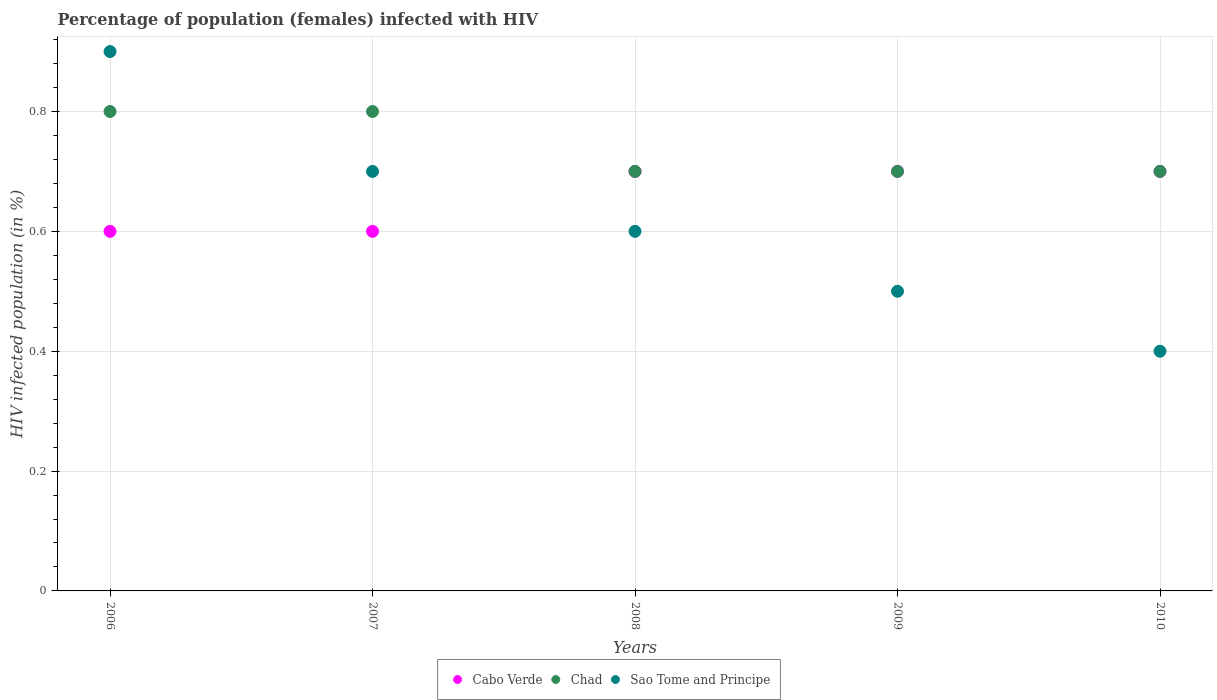Is the number of dotlines equal to the number of legend labels?
Your answer should be very brief. Yes. What is the percentage of HIV infected female population in Cabo Verde in 2008?
Your answer should be compact. 0.7. Across all years, what is the maximum percentage of HIV infected female population in Chad?
Offer a terse response. 0.8. Across all years, what is the minimum percentage of HIV infected female population in Chad?
Ensure brevity in your answer.  0.7. What is the total percentage of HIV infected female population in Cabo Verde in the graph?
Your answer should be very brief. 3.3. What is the difference between the percentage of HIV infected female population in Chad in 2007 and the percentage of HIV infected female population in Sao Tome and Principe in 2010?
Offer a terse response. 0.4. What is the average percentage of HIV infected female population in Cabo Verde per year?
Keep it short and to the point. 0.66. In the year 2007, what is the difference between the percentage of HIV infected female population in Sao Tome and Principe and percentage of HIV infected female population in Cabo Verde?
Offer a very short reply. 0.1. What is the ratio of the percentage of HIV infected female population in Sao Tome and Principe in 2006 to that in 2010?
Make the answer very short. 2.25. What is the difference between the highest and the second highest percentage of HIV infected female population in Cabo Verde?
Ensure brevity in your answer.  0. What is the difference between the highest and the lowest percentage of HIV infected female population in Chad?
Your response must be concise. 0.1. Is the sum of the percentage of HIV infected female population in Cabo Verde in 2007 and 2010 greater than the maximum percentage of HIV infected female population in Chad across all years?
Your answer should be very brief. Yes. Is it the case that in every year, the sum of the percentage of HIV infected female population in Sao Tome and Principe and percentage of HIV infected female population in Chad  is greater than the percentage of HIV infected female population in Cabo Verde?
Offer a very short reply. Yes. Does the percentage of HIV infected female population in Cabo Verde monotonically increase over the years?
Ensure brevity in your answer.  No. Is the percentage of HIV infected female population in Cabo Verde strictly greater than the percentage of HIV infected female population in Chad over the years?
Provide a succinct answer. No. How many years are there in the graph?
Your response must be concise. 5. What is the difference between two consecutive major ticks on the Y-axis?
Keep it short and to the point. 0.2. Where does the legend appear in the graph?
Your response must be concise. Bottom center. How many legend labels are there?
Your answer should be compact. 3. How are the legend labels stacked?
Your answer should be very brief. Horizontal. What is the title of the graph?
Offer a very short reply. Percentage of population (females) infected with HIV. What is the label or title of the Y-axis?
Ensure brevity in your answer.  HIV infected population (in %). What is the HIV infected population (in %) of Chad in 2006?
Your answer should be very brief. 0.8. What is the HIV infected population (in %) of Sao Tome and Principe in 2006?
Provide a succinct answer. 0.9. What is the HIV infected population (in %) in Cabo Verde in 2007?
Your response must be concise. 0.6. What is the HIV infected population (in %) of Chad in 2007?
Ensure brevity in your answer.  0.8. What is the HIV infected population (in %) in Cabo Verde in 2008?
Provide a short and direct response. 0.7. What is the HIV infected population (in %) in Chad in 2008?
Your answer should be very brief. 0.7. What is the HIV infected population (in %) in Sao Tome and Principe in 2009?
Provide a short and direct response. 0.5. What is the HIV infected population (in %) of Chad in 2010?
Your answer should be very brief. 0.7. Across all years, what is the maximum HIV infected population (in %) of Chad?
Your answer should be very brief. 0.8. Across all years, what is the maximum HIV infected population (in %) in Sao Tome and Principe?
Keep it short and to the point. 0.9. What is the total HIV infected population (in %) in Cabo Verde in the graph?
Keep it short and to the point. 3.3. What is the difference between the HIV infected population (in %) of Chad in 2006 and that in 2007?
Offer a very short reply. 0. What is the difference between the HIV infected population (in %) of Sao Tome and Principe in 2006 and that in 2007?
Your response must be concise. 0.2. What is the difference between the HIV infected population (in %) of Chad in 2006 and that in 2008?
Provide a succinct answer. 0.1. What is the difference between the HIV infected population (in %) of Sao Tome and Principe in 2006 and that in 2008?
Your answer should be compact. 0.3. What is the difference between the HIV infected population (in %) in Cabo Verde in 2006 and that in 2009?
Offer a terse response. -0.1. What is the difference between the HIV infected population (in %) in Sao Tome and Principe in 2006 and that in 2009?
Offer a terse response. 0.4. What is the difference between the HIV infected population (in %) in Cabo Verde in 2006 and that in 2010?
Keep it short and to the point. -0.1. What is the difference between the HIV infected population (in %) in Chad in 2006 and that in 2010?
Your answer should be very brief. 0.1. What is the difference between the HIV infected population (in %) in Cabo Verde in 2007 and that in 2008?
Provide a succinct answer. -0.1. What is the difference between the HIV infected population (in %) of Chad in 2007 and that in 2008?
Provide a succinct answer. 0.1. What is the difference between the HIV infected population (in %) in Chad in 2007 and that in 2009?
Give a very brief answer. 0.1. What is the difference between the HIV infected population (in %) of Cabo Verde in 2007 and that in 2010?
Provide a succinct answer. -0.1. What is the difference between the HIV infected population (in %) of Cabo Verde in 2008 and that in 2009?
Ensure brevity in your answer.  0. What is the difference between the HIV infected population (in %) in Chad in 2008 and that in 2010?
Your answer should be very brief. 0. What is the difference between the HIV infected population (in %) in Cabo Verde in 2009 and that in 2010?
Your answer should be very brief. 0. What is the difference between the HIV infected population (in %) of Chad in 2009 and that in 2010?
Keep it short and to the point. 0. What is the difference between the HIV infected population (in %) in Chad in 2006 and the HIV infected population (in %) in Sao Tome and Principe in 2007?
Provide a short and direct response. 0.1. What is the difference between the HIV infected population (in %) of Cabo Verde in 2006 and the HIV infected population (in %) of Chad in 2008?
Offer a terse response. -0.1. What is the difference between the HIV infected population (in %) of Cabo Verde in 2006 and the HIV infected population (in %) of Sao Tome and Principe in 2008?
Offer a very short reply. 0. What is the difference between the HIV infected population (in %) of Cabo Verde in 2006 and the HIV infected population (in %) of Chad in 2009?
Ensure brevity in your answer.  -0.1. What is the difference between the HIV infected population (in %) of Chad in 2006 and the HIV infected population (in %) of Sao Tome and Principe in 2009?
Provide a short and direct response. 0.3. What is the difference between the HIV infected population (in %) of Cabo Verde in 2006 and the HIV infected population (in %) of Chad in 2010?
Provide a succinct answer. -0.1. What is the difference between the HIV infected population (in %) in Chad in 2006 and the HIV infected population (in %) in Sao Tome and Principe in 2010?
Offer a terse response. 0.4. What is the difference between the HIV infected population (in %) in Cabo Verde in 2007 and the HIV infected population (in %) in Chad in 2008?
Your answer should be very brief. -0.1. What is the difference between the HIV infected population (in %) in Chad in 2007 and the HIV infected population (in %) in Sao Tome and Principe in 2008?
Make the answer very short. 0.2. What is the difference between the HIV infected population (in %) of Cabo Verde in 2007 and the HIV infected population (in %) of Chad in 2009?
Your response must be concise. -0.1. What is the difference between the HIV infected population (in %) in Cabo Verde in 2007 and the HIV infected population (in %) in Sao Tome and Principe in 2009?
Give a very brief answer. 0.1. What is the difference between the HIV infected population (in %) of Cabo Verde in 2007 and the HIV infected population (in %) of Chad in 2010?
Your answer should be very brief. -0.1. What is the difference between the HIV infected population (in %) of Cabo Verde in 2007 and the HIV infected population (in %) of Sao Tome and Principe in 2010?
Keep it short and to the point. 0.2. What is the difference between the HIV infected population (in %) of Chad in 2007 and the HIV infected population (in %) of Sao Tome and Principe in 2010?
Give a very brief answer. 0.4. What is the difference between the HIV infected population (in %) in Cabo Verde in 2008 and the HIV infected population (in %) in Chad in 2009?
Provide a short and direct response. 0. What is the difference between the HIV infected population (in %) of Cabo Verde in 2008 and the HIV infected population (in %) of Chad in 2010?
Your answer should be compact. 0. What is the difference between the HIV infected population (in %) of Cabo Verde in 2008 and the HIV infected population (in %) of Sao Tome and Principe in 2010?
Your response must be concise. 0.3. What is the difference between the HIV infected population (in %) of Cabo Verde in 2009 and the HIV infected population (in %) of Chad in 2010?
Provide a succinct answer. 0. What is the average HIV infected population (in %) in Cabo Verde per year?
Offer a very short reply. 0.66. What is the average HIV infected population (in %) in Chad per year?
Provide a succinct answer. 0.74. What is the average HIV infected population (in %) in Sao Tome and Principe per year?
Offer a terse response. 0.62. In the year 2006, what is the difference between the HIV infected population (in %) in Cabo Verde and HIV infected population (in %) in Sao Tome and Principe?
Your answer should be very brief. -0.3. In the year 2007, what is the difference between the HIV infected population (in %) in Cabo Verde and HIV infected population (in %) in Chad?
Give a very brief answer. -0.2. In the year 2007, what is the difference between the HIV infected population (in %) in Cabo Verde and HIV infected population (in %) in Sao Tome and Principe?
Offer a very short reply. -0.1. In the year 2007, what is the difference between the HIV infected population (in %) of Chad and HIV infected population (in %) of Sao Tome and Principe?
Ensure brevity in your answer.  0.1. In the year 2008, what is the difference between the HIV infected population (in %) of Cabo Verde and HIV infected population (in %) of Sao Tome and Principe?
Your answer should be very brief. 0.1. In the year 2008, what is the difference between the HIV infected population (in %) in Chad and HIV infected population (in %) in Sao Tome and Principe?
Your response must be concise. 0.1. In the year 2009, what is the difference between the HIV infected population (in %) of Cabo Verde and HIV infected population (in %) of Chad?
Offer a very short reply. 0. In the year 2009, what is the difference between the HIV infected population (in %) in Chad and HIV infected population (in %) in Sao Tome and Principe?
Offer a very short reply. 0.2. In the year 2010, what is the difference between the HIV infected population (in %) of Cabo Verde and HIV infected population (in %) of Chad?
Give a very brief answer. 0. In the year 2010, what is the difference between the HIV infected population (in %) in Chad and HIV infected population (in %) in Sao Tome and Principe?
Your response must be concise. 0.3. What is the ratio of the HIV infected population (in %) of Cabo Verde in 2006 to that in 2007?
Keep it short and to the point. 1. What is the ratio of the HIV infected population (in %) of Chad in 2006 to that in 2007?
Provide a short and direct response. 1. What is the ratio of the HIV infected population (in %) in Sao Tome and Principe in 2006 to that in 2007?
Keep it short and to the point. 1.29. What is the ratio of the HIV infected population (in %) of Cabo Verde in 2006 to that in 2009?
Your answer should be compact. 0.86. What is the ratio of the HIV infected population (in %) of Cabo Verde in 2006 to that in 2010?
Keep it short and to the point. 0.86. What is the ratio of the HIV infected population (in %) in Sao Tome and Principe in 2006 to that in 2010?
Offer a terse response. 2.25. What is the ratio of the HIV infected population (in %) of Sao Tome and Principe in 2007 to that in 2008?
Offer a very short reply. 1.17. What is the ratio of the HIV infected population (in %) of Cabo Verde in 2007 to that in 2009?
Ensure brevity in your answer.  0.86. What is the ratio of the HIV infected population (in %) of Chad in 2007 to that in 2009?
Offer a terse response. 1.14. What is the ratio of the HIV infected population (in %) in Sao Tome and Principe in 2007 to that in 2009?
Your answer should be very brief. 1.4. What is the ratio of the HIV infected population (in %) of Cabo Verde in 2007 to that in 2010?
Provide a short and direct response. 0.86. What is the ratio of the HIV infected population (in %) of Chad in 2007 to that in 2010?
Your answer should be compact. 1.14. What is the ratio of the HIV infected population (in %) in Sao Tome and Principe in 2007 to that in 2010?
Your answer should be compact. 1.75. What is the ratio of the HIV infected population (in %) in Cabo Verde in 2008 to that in 2009?
Provide a short and direct response. 1. What is the ratio of the HIV infected population (in %) of Chad in 2008 to that in 2009?
Make the answer very short. 1. What is the ratio of the HIV infected population (in %) in Sao Tome and Principe in 2008 to that in 2009?
Offer a very short reply. 1.2. What is the ratio of the HIV infected population (in %) in Cabo Verde in 2008 to that in 2010?
Your answer should be very brief. 1. What is the ratio of the HIV infected population (in %) of Cabo Verde in 2009 to that in 2010?
Keep it short and to the point. 1. What is the ratio of the HIV infected population (in %) of Sao Tome and Principe in 2009 to that in 2010?
Keep it short and to the point. 1.25. What is the difference between the highest and the second highest HIV infected population (in %) in Cabo Verde?
Offer a terse response. 0. What is the difference between the highest and the second highest HIV infected population (in %) of Chad?
Your answer should be very brief. 0. What is the difference between the highest and the lowest HIV infected population (in %) in Cabo Verde?
Your answer should be very brief. 0.1. What is the difference between the highest and the lowest HIV infected population (in %) in Sao Tome and Principe?
Keep it short and to the point. 0.5. 